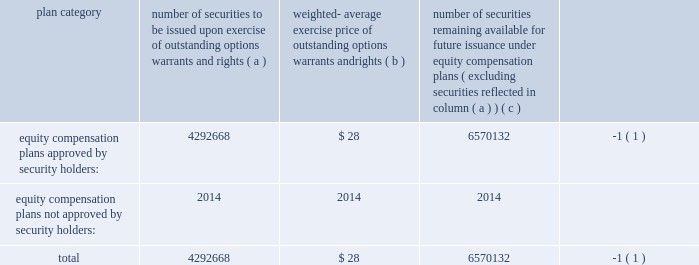Item 12 2014security ownership of certain beneficial owners and management and related stockholder matters we incorporate by reference in this item 12 the information relating to ownership of our common stock by certain persons contained under the headings 201ccommon stock ownership of management 201d and 201ccommon stock ownership by certain other persons 201d from our proxy statement to be delivered in connection with our 2009 annual meeting of shareholders to be held on september 30 , 2009 .
We have four compensation plans under which our equity securities are authorized for issuance .
The global payments inc .
Amended and restated 2000 long-term incentive plan , global payments inc .
Amended and restated 2005 incentive plan , the non-employee director stock option plan , and employee stock purchase plan have been approved by security holders .
The information in the table below is as of may 31 , 2009 .
For more information on these plans , see note 11 to notes to consolidated financial statements .
Plan category number of securities to be issued upon exercise of outstanding options , warrants and rights weighted- average exercise price of outstanding options , warrants and rights number of securities remaining available for future issuance under equity compensation plans ( excluding securities reflected in column ( a ) ) equity compensation plans approved by security holders: .
4292668 $ 28 6570132 ( 1 ) equity compensation plans not approved by security holders: .
2014 2014 2014 .
( 1 ) also includes shares of common stock available for issuance other than upon the exercise of an option , warrant or right under the global payments inc .
2000 long-term incentive plan , as amended and restated , the global payments inc .
Amended and restated 2005 incentive plan and an amended and restated 2000 non-employee director stock option plan .
Item 13 2014certain relationships and related transactions , and director independence we incorporate by reference in this item 13 the information regarding certain relationships and related transactions between us and some of our affiliates and the independence of our board of directors contained under the headings 201ccertain relationships and related transactions 201d and 201cother information about the board and its committees 2014director independence 201d from our proxy statement to be delivered in connection with our 2009 annual meeting of shareholders to be held on september 30 , 2009 .
Item 14 2014principal accounting fees and services we incorporate by reference in this item 14 the information regarding principal accounting fees and services contained under the heading 201cauditor information 201d from our proxy statement to be delivered in connection with our 2009 annual meeting of shareholders to be held on september 30 , 2009. .
What is the total value of securities approved by security holders that remain to be issued in the future , ( in millions ) ? 
Computations: ((6570132 * 28) / 1000000)
Answer: 183.9637. 